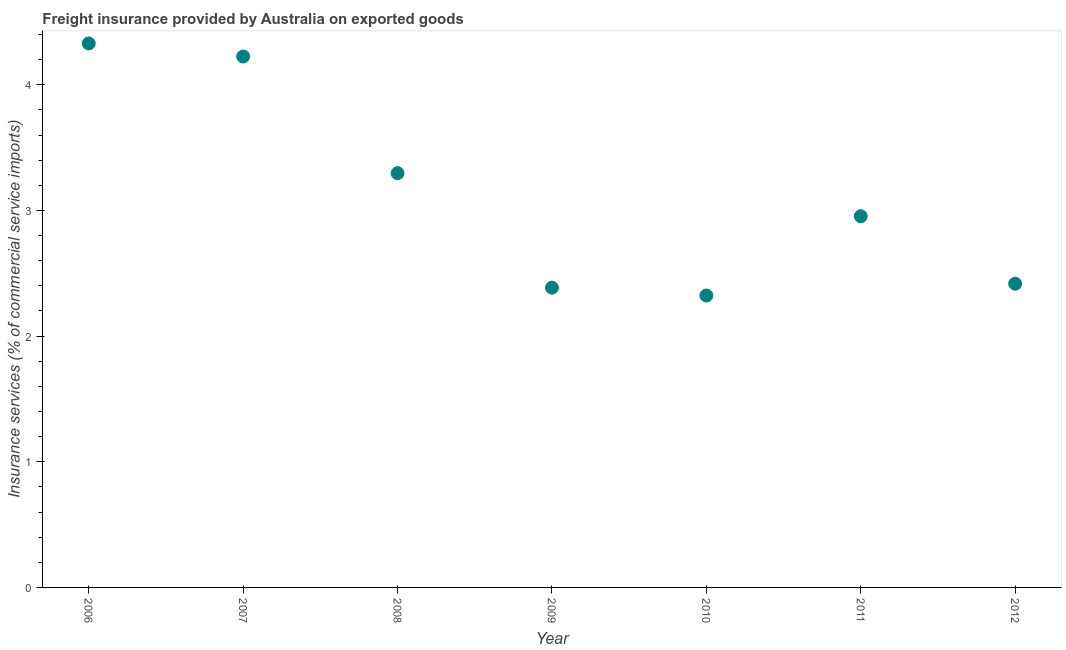What is the freight insurance in 2012?
Your answer should be compact. 2.42. Across all years, what is the maximum freight insurance?
Offer a very short reply. 4.33. Across all years, what is the minimum freight insurance?
Offer a terse response. 2.32. In which year was the freight insurance minimum?
Provide a succinct answer. 2010. What is the sum of the freight insurance?
Offer a terse response. 21.93. What is the difference between the freight insurance in 2008 and 2009?
Ensure brevity in your answer.  0.91. What is the average freight insurance per year?
Your answer should be very brief. 3.13. What is the median freight insurance?
Provide a short and direct response. 2.95. In how many years, is the freight insurance greater than 2.6 %?
Provide a short and direct response. 4. What is the ratio of the freight insurance in 2007 to that in 2010?
Offer a very short reply. 1.82. Is the freight insurance in 2006 less than that in 2010?
Your answer should be very brief. No. Is the difference between the freight insurance in 2007 and 2012 greater than the difference between any two years?
Keep it short and to the point. No. What is the difference between the highest and the second highest freight insurance?
Offer a very short reply. 0.1. What is the difference between the highest and the lowest freight insurance?
Ensure brevity in your answer.  2.01. Does the freight insurance monotonically increase over the years?
Make the answer very short. No. How many dotlines are there?
Provide a short and direct response. 1. Are the values on the major ticks of Y-axis written in scientific E-notation?
Keep it short and to the point. No. Does the graph contain grids?
Make the answer very short. No. What is the title of the graph?
Your answer should be very brief. Freight insurance provided by Australia on exported goods . What is the label or title of the X-axis?
Ensure brevity in your answer.  Year. What is the label or title of the Y-axis?
Give a very brief answer. Insurance services (% of commercial service imports). What is the Insurance services (% of commercial service imports) in 2006?
Your response must be concise. 4.33. What is the Insurance services (% of commercial service imports) in 2007?
Provide a short and direct response. 4.23. What is the Insurance services (% of commercial service imports) in 2008?
Make the answer very short. 3.3. What is the Insurance services (% of commercial service imports) in 2009?
Make the answer very short. 2.39. What is the Insurance services (% of commercial service imports) in 2010?
Keep it short and to the point. 2.32. What is the Insurance services (% of commercial service imports) in 2011?
Your answer should be very brief. 2.95. What is the Insurance services (% of commercial service imports) in 2012?
Your answer should be very brief. 2.42. What is the difference between the Insurance services (% of commercial service imports) in 2006 and 2007?
Your response must be concise. 0.1. What is the difference between the Insurance services (% of commercial service imports) in 2006 and 2008?
Your answer should be compact. 1.03. What is the difference between the Insurance services (% of commercial service imports) in 2006 and 2009?
Your answer should be compact. 1.94. What is the difference between the Insurance services (% of commercial service imports) in 2006 and 2010?
Your answer should be very brief. 2.01. What is the difference between the Insurance services (% of commercial service imports) in 2006 and 2011?
Offer a terse response. 1.38. What is the difference between the Insurance services (% of commercial service imports) in 2006 and 2012?
Provide a short and direct response. 1.91. What is the difference between the Insurance services (% of commercial service imports) in 2007 and 2008?
Give a very brief answer. 0.93. What is the difference between the Insurance services (% of commercial service imports) in 2007 and 2009?
Offer a terse response. 1.84. What is the difference between the Insurance services (% of commercial service imports) in 2007 and 2010?
Provide a succinct answer. 1.9. What is the difference between the Insurance services (% of commercial service imports) in 2007 and 2011?
Offer a very short reply. 1.27. What is the difference between the Insurance services (% of commercial service imports) in 2007 and 2012?
Provide a short and direct response. 1.81. What is the difference between the Insurance services (% of commercial service imports) in 2008 and 2009?
Offer a terse response. 0.91. What is the difference between the Insurance services (% of commercial service imports) in 2008 and 2010?
Your answer should be very brief. 0.97. What is the difference between the Insurance services (% of commercial service imports) in 2008 and 2011?
Your answer should be compact. 0.34. What is the difference between the Insurance services (% of commercial service imports) in 2008 and 2012?
Offer a terse response. 0.88. What is the difference between the Insurance services (% of commercial service imports) in 2009 and 2010?
Give a very brief answer. 0.06. What is the difference between the Insurance services (% of commercial service imports) in 2009 and 2011?
Provide a succinct answer. -0.57. What is the difference between the Insurance services (% of commercial service imports) in 2009 and 2012?
Offer a very short reply. -0.03. What is the difference between the Insurance services (% of commercial service imports) in 2010 and 2011?
Ensure brevity in your answer.  -0.63. What is the difference between the Insurance services (% of commercial service imports) in 2010 and 2012?
Give a very brief answer. -0.09. What is the difference between the Insurance services (% of commercial service imports) in 2011 and 2012?
Offer a terse response. 0.54. What is the ratio of the Insurance services (% of commercial service imports) in 2006 to that in 2008?
Your response must be concise. 1.31. What is the ratio of the Insurance services (% of commercial service imports) in 2006 to that in 2009?
Make the answer very short. 1.81. What is the ratio of the Insurance services (% of commercial service imports) in 2006 to that in 2010?
Keep it short and to the point. 1.86. What is the ratio of the Insurance services (% of commercial service imports) in 2006 to that in 2011?
Keep it short and to the point. 1.47. What is the ratio of the Insurance services (% of commercial service imports) in 2006 to that in 2012?
Provide a short and direct response. 1.79. What is the ratio of the Insurance services (% of commercial service imports) in 2007 to that in 2008?
Your answer should be compact. 1.28. What is the ratio of the Insurance services (% of commercial service imports) in 2007 to that in 2009?
Give a very brief answer. 1.77. What is the ratio of the Insurance services (% of commercial service imports) in 2007 to that in 2010?
Your answer should be very brief. 1.82. What is the ratio of the Insurance services (% of commercial service imports) in 2007 to that in 2011?
Provide a short and direct response. 1.43. What is the ratio of the Insurance services (% of commercial service imports) in 2007 to that in 2012?
Give a very brief answer. 1.75. What is the ratio of the Insurance services (% of commercial service imports) in 2008 to that in 2009?
Ensure brevity in your answer.  1.38. What is the ratio of the Insurance services (% of commercial service imports) in 2008 to that in 2010?
Provide a succinct answer. 1.42. What is the ratio of the Insurance services (% of commercial service imports) in 2008 to that in 2011?
Your answer should be very brief. 1.12. What is the ratio of the Insurance services (% of commercial service imports) in 2008 to that in 2012?
Make the answer very short. 1.36. What is the ratio of the Insurance services (% of commercial service imports) in 2009 to that in 2010?
Your answer should be compact. 1.03. What is the ratio of the Insurance services (% of commercial service imports) in 2009 to that in 2011?
Your response must be concise. 0.81. What is the ratio of the Insurance services (% of commercial service imports) in 2009 to that in 2012?
Your answer should be compact. 0.99. What is the ratio of the Insurance services (% of commercial service imports) in 2010 to that in 2011?
Your answer should be compact. 0.79. What is the ratio of the Insurance services (% of commercial service imports) in 2010 to that in 2012?
Your answer should be very brief. 0.96. What is the ratio of the Insurance services (% of commercial service imports) in 2011 to that in 2012?
Your answer should be compact. 1.22. 